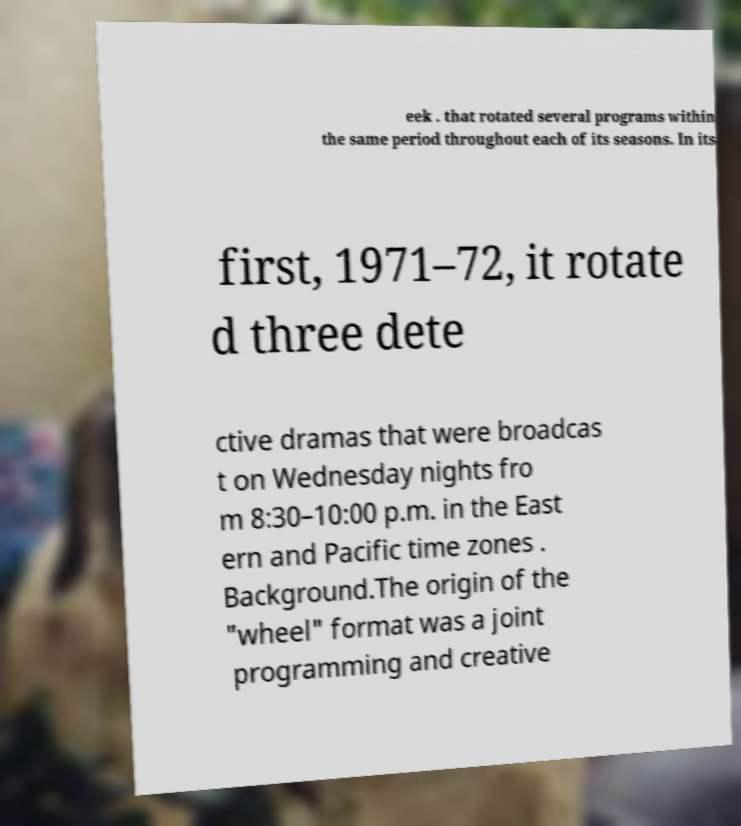Could you extract and type out the text from this image? eek . that rotated several programs within the same period throughout each of its seasons. In its first, 1971–72, it rotate d three dete ctive dramas that were broadcas t on Wednesday nights fro m 8:30–10:00 p.m. in the East ern and Pacific time zones . Background.The origin of the "wheel" format was a joint programming and creative 